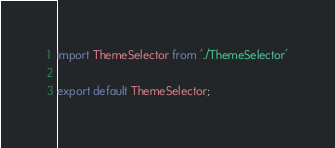<code> <loc_0><loc_0><loc_500><loc_500><_JavaScript_>
import ThemeSelector from './ThemeSelector'

export default ThemeSelector; 
</code> 